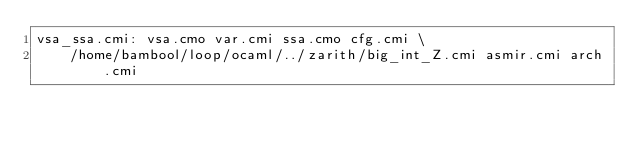Convert code to text. <code><loc_0><loc_0><loc_500><loc_500><_D_>vsa_ssa.cmi: vsa.cmo var.cmi ssa.cmo cfg.cmi \
    /home/bambool/loop/ocaml/../zarith/big_int_Z.cmi asmir.cmi arch.cmi
</code> 